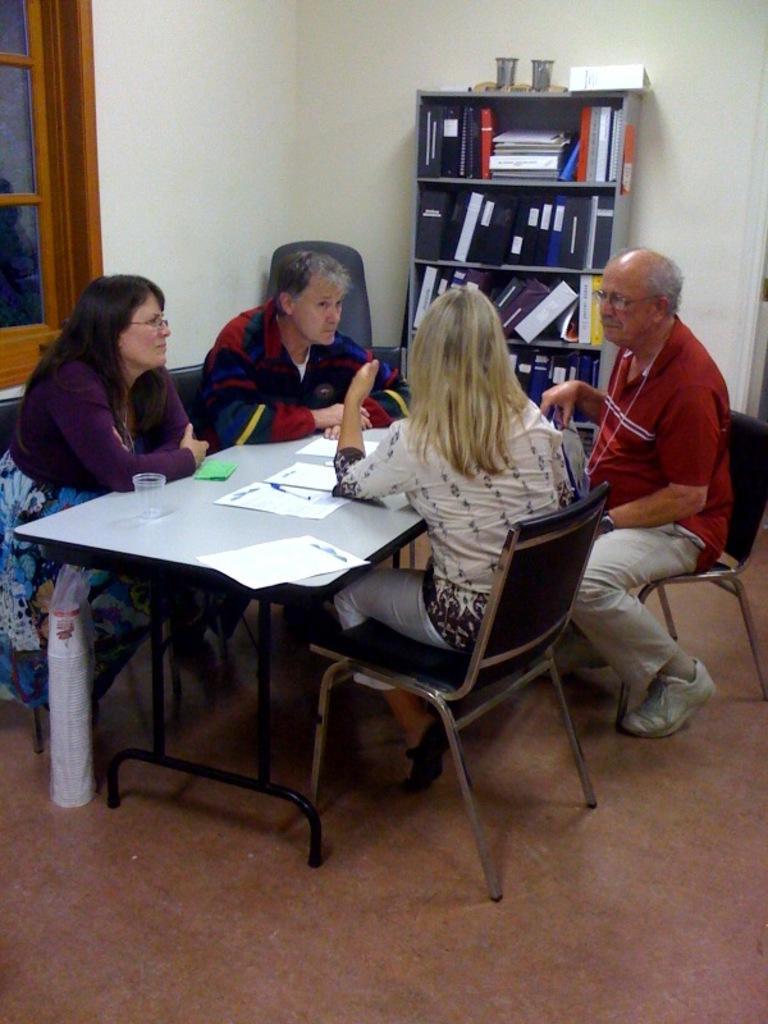Describe this image in one or two sentences. This persons are sitting on chair. This rack is filled with files. On this table there is a paper, pen and glass. Under the table there is a paper cups. This is window. 